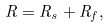<formula> <loc_0><loc_0><loc_500><loc_500>R = R _ { s } + R _ { f } ,</formula> 